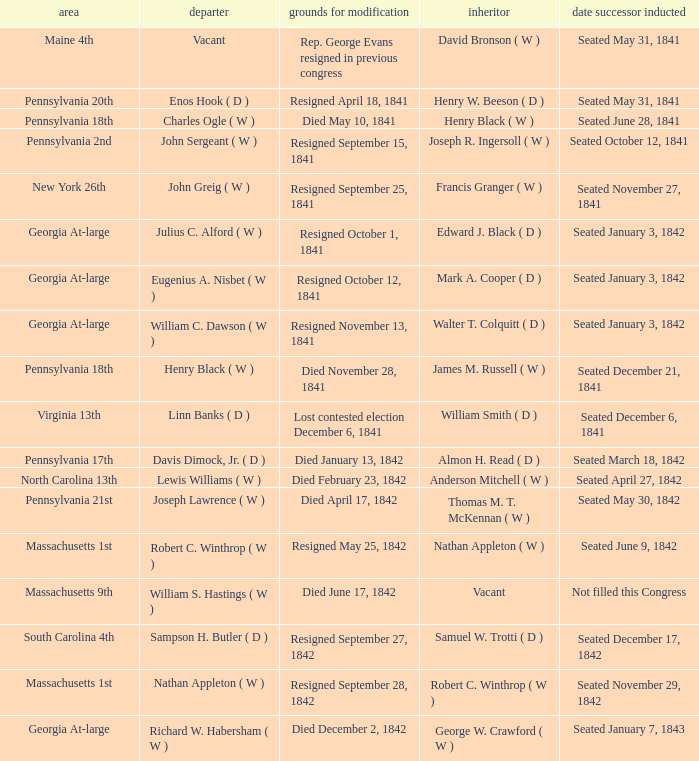Identify the successor for north carolina's 13th district. Anderson Mitchell ( W ). 